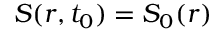Convert formula to latex. <formula><loc_0><loc_0><loc_500><loc_500>S ( r , t _ { 0 } ) = S _ { 0 } ( r )</formula> 